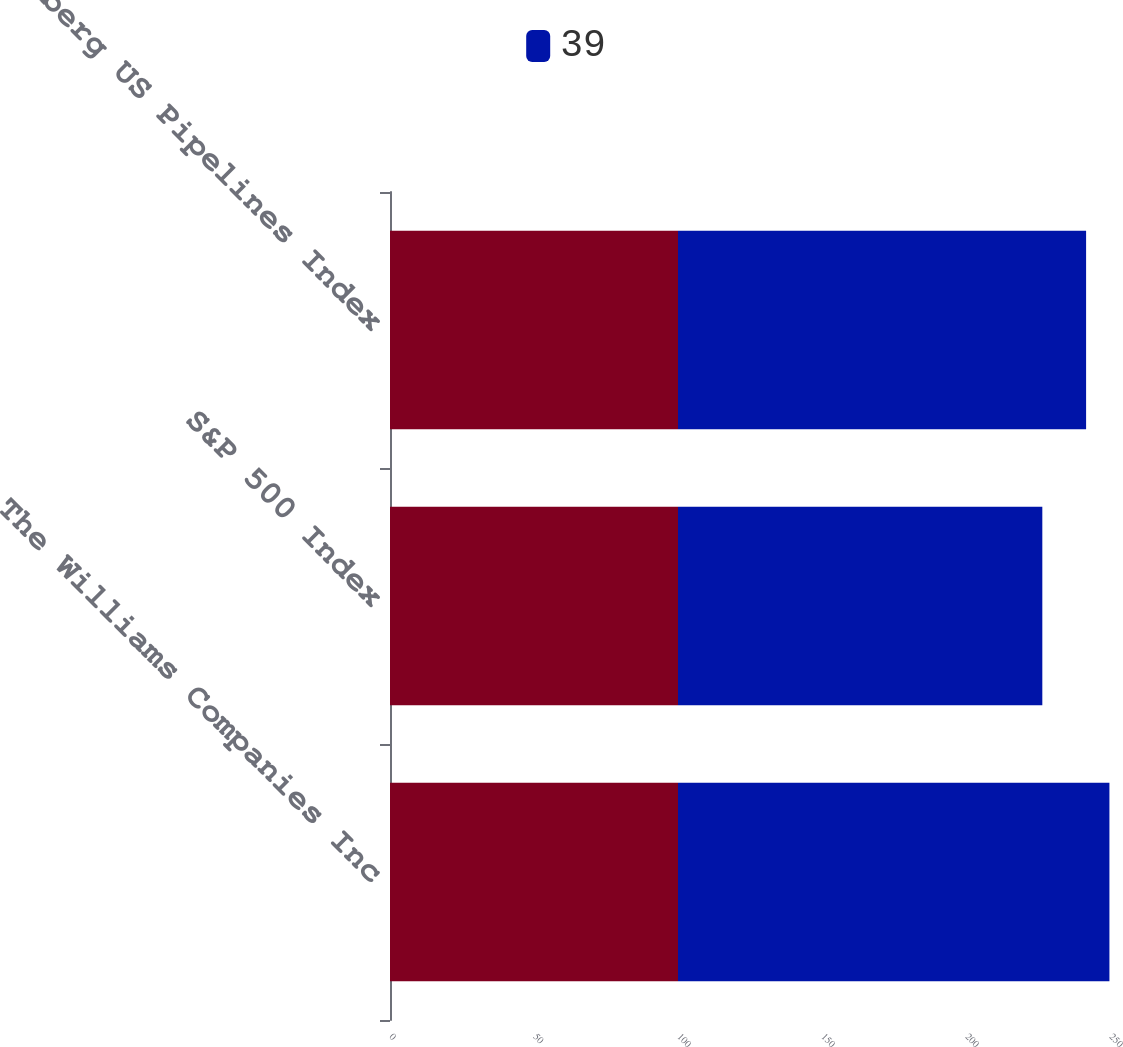Convert chart to OTSL. <chart><loc_0><loc_0><loc_500><loc_500><stacked_bar_chart><ecel><fcel>The Williams Companies Inc<fcel>S&P 500 Index<fcel>Bloomberg US Pipelines Index<nl><fcel>nan<fcel>100<fcel>100<fcel>100<nl><fcel>39<fcel>149.8<fcel>126.5<fcel>141.7<nl></chart> 